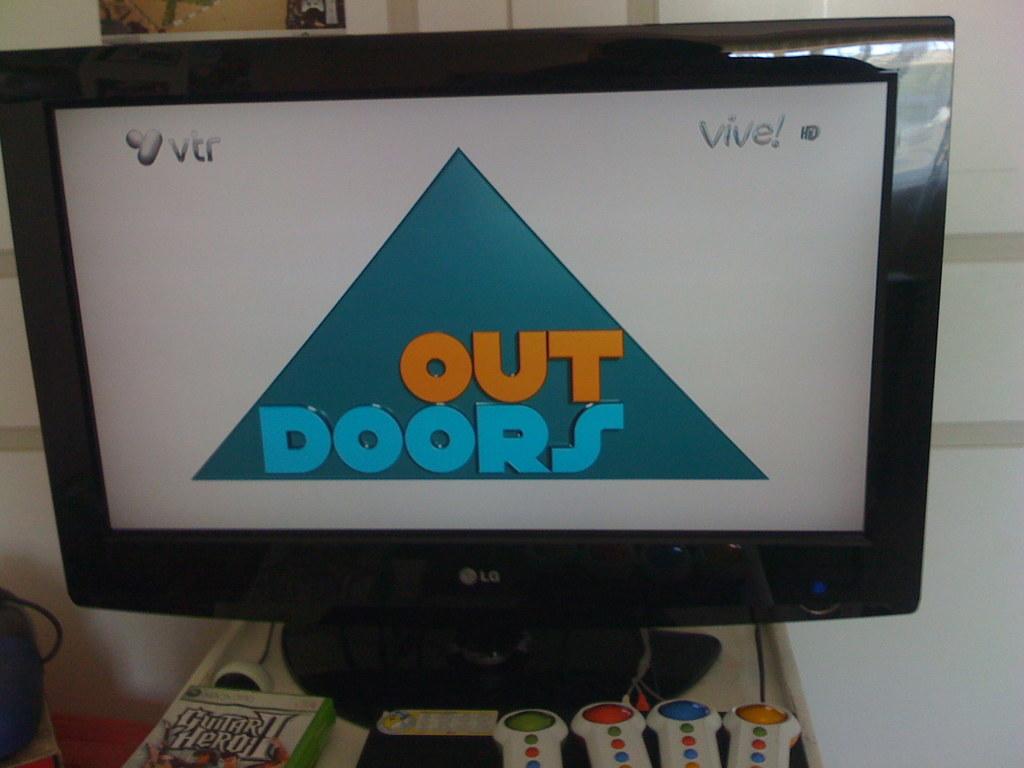What word is written in the triangle?
Offer a very short reply. Out doors. What is the company on the top left of the screen?
Your answer should be very brief. Vtr. 